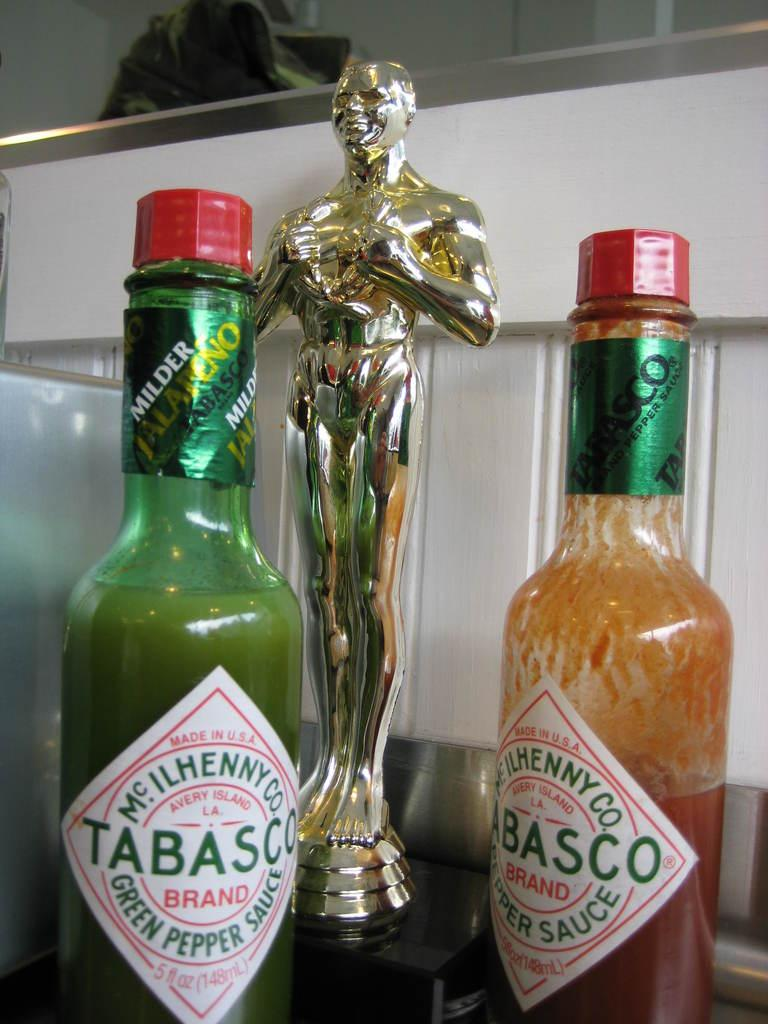<image>
Summarize the visual content of the image. two bottles of tabasco standing next to each other 